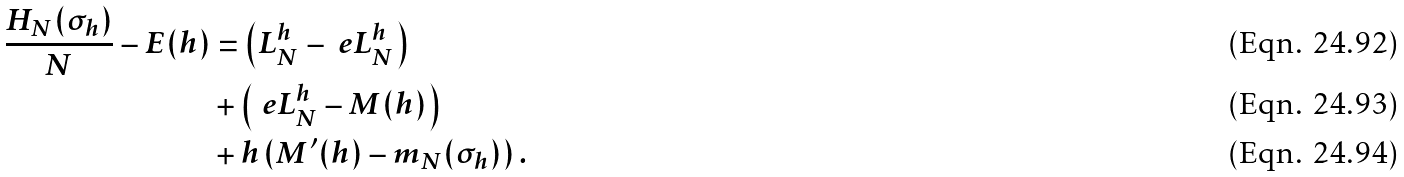Convert formula to latex. <formula><loc_0><loc_0><loc_500><loc_500>\frac { H _ { N } ( \sigma _ { h } ) } { N } - E ( h ) & = \left ( L _ { N } ^ { h } - \ e L _ { N } ^ { h } \right ) \\ & + \left ( \ e L _ { N } ^ { h } - M ( h ) \right ) \\ & + h \left ( M ^ { \prime } ( h ) - m _ { N } ( \sigma _ { h } ) \right ) .</formula> 